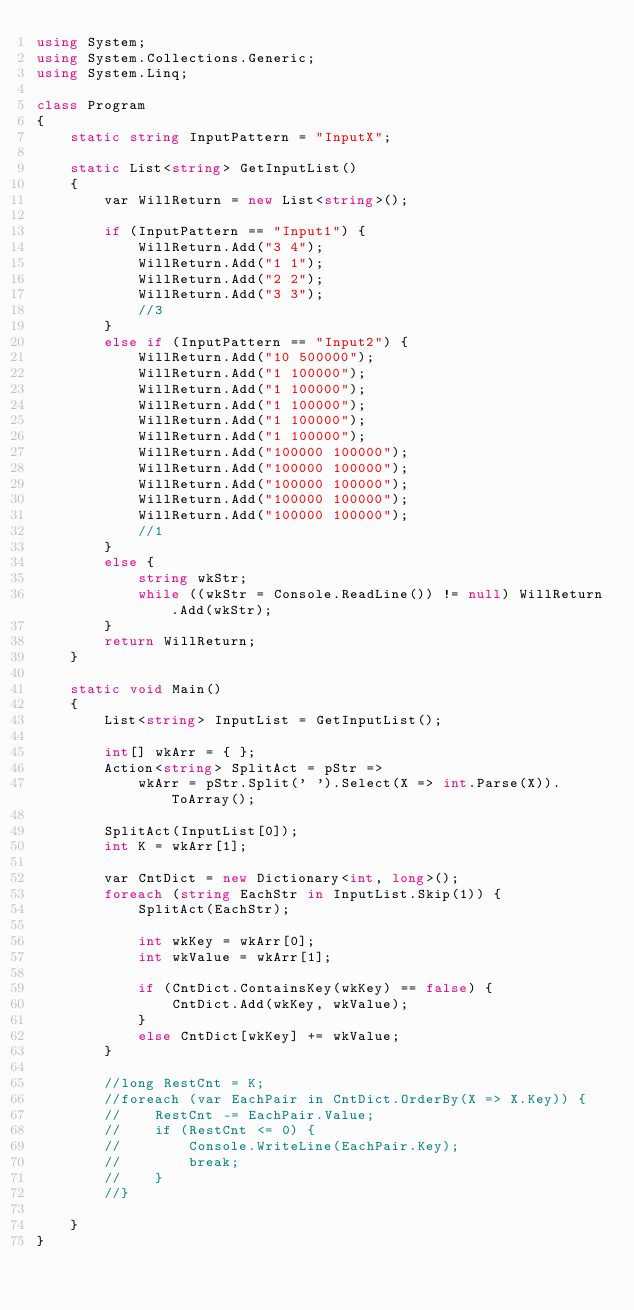<code> <loc_0><loc_0><loc_500><loc_500><_C#_>using System;
using System.Collections.Generic;
using System.Linq;

class Program
{
    static string InputPattern = "InputX";

    static List<string> GetInputList()
    {
        var WillReturn = new List<string>();

        if (InputPattern == "Input1") {
            WillReturn.Add("3 4");
            WillReturn.Add("1 1");
            WillReturn.Add("2 2");
            WillReturn.Add("3 3");
            //3
        }
        else if (InputPattern == "Input2") {
            WillReturn.Add("10 500000");
            WillReturn.Add("1 100000");
            WillReturn.Add("1 100000");
            WillReturn.Add("1 100000");
            WillReturn.Add("1 100000");
            WillReturn.Add("1 100000");
            WillReturn.Add("100000 100000");
            WillReturn.Add("100000 100000");
            WillReturn.Add("100000 100000");
            WillReturn.Add("100000 100000");
            WillReturn.Add("100000 100000");
            //1
        }
        else {
            string wkStr;
            while ((wkStr = Console.ReadLine()) != null) WillReturn.Add(wkStr);
        }
        return WillReturn;
    }

    static void Main()
    {
        List<string> InputList = GetInputList();

        int[] wkArr = { };
        Action<string> SplitAct = pStr =>
            wkArr = pStr.Split(' ').Select(X => int.Parse(X)).ToArray();

        SplitAct(InputList[0]);
        int K = wkArr[1];

        var CntDict = new Dictionary<int, long>();
        foreach (string EachStr in InputList.Skip(1)) {
            SplitAct(EachStr);

            int wkKey = wkArr[0];
            int wkValue = wkArr[1];

            if (CntDict.ContainsKey(wkKey) == false) {
                CntDict.Add(wkKey, wkValue);
            }
            else CntDict[wkKey] += wkValue;
        }

        //long RestCnt = K;
        //foreach (var EachPair in CntDict.OrderBy(X => X.Key)) {
        //    RestCnt -= EachPair.Value;
        //    if (RestCnt <= 0) {
        //        Console.WriteLine(EachPair.Key);
        //        break;
        //    }
        //}

    }
}
</code> 